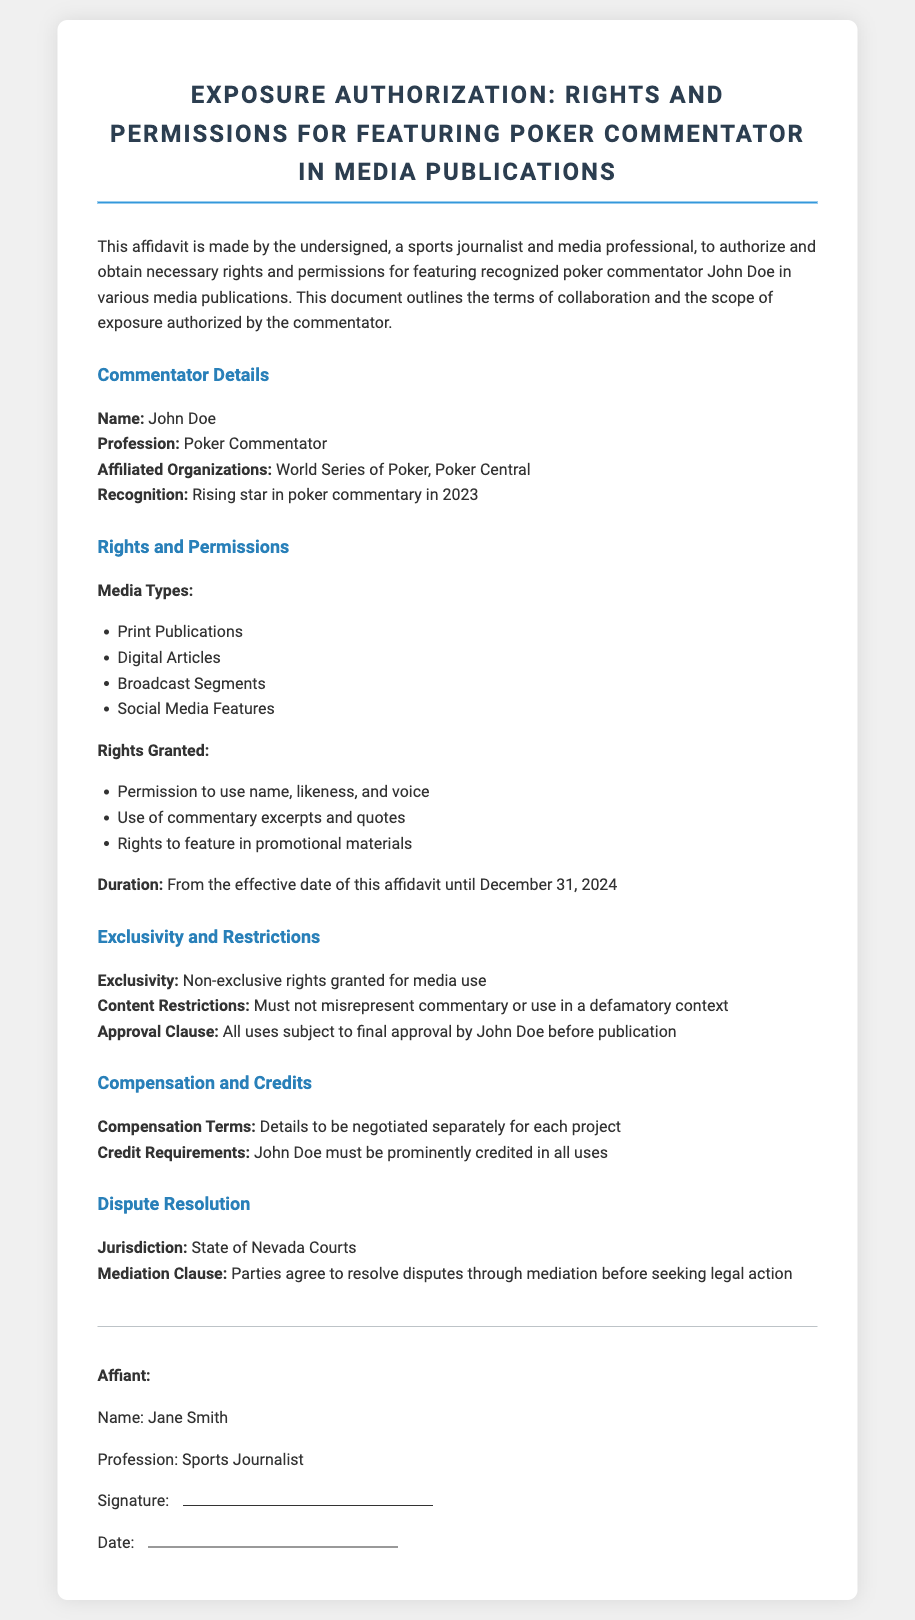What is the name of the commentator? The document specifies the name of the commentator, which is John Doe.
Answer: John Doe What is the effective date of the affidavit? The document does not specify the exact effective date, but it states the duration begins from the effective date until December 31, 2024.
Answer: Not specified What types of media are authorized for use? The document lists various media types authorized for use, including print publications, digital articles, broadcast segments, and social media features.
Answer: Print Publications, Digital Articles, Broadcast Segments, Social Media Features Where will disputes be resolved? The affidavit identifies the jurisdiction for dispute resolution as the State of Nevada Courts.
Answer: State of Nevada Courts What must be provided in all media uses featuring John Doe? The document states that John Doe must be prominently credited in all uses, specifying credit requirements.
Answer: Prominently credited What is the duration of the rights granted? The document specifies that the rights are granted until December 31, 2024.
Answer: December 31, 2024 What type of rights are granted in the affidavit? The rights granted include permission to use name, likeness, and voice, along with commentary excerpts and quotes.
Answer: Permission to use name, likeness, and voice What clause requires approval before publication? The document mentions an approval clause, which stipulates that all uses are subject to final approval by John Doe before publication.
Answer: Approval Clause What is the compensation terms stated in the affidavit? The affidavit indicates that compensation terms are to be negotiated separately for each project.
Answer: Negotiated separately for each project 